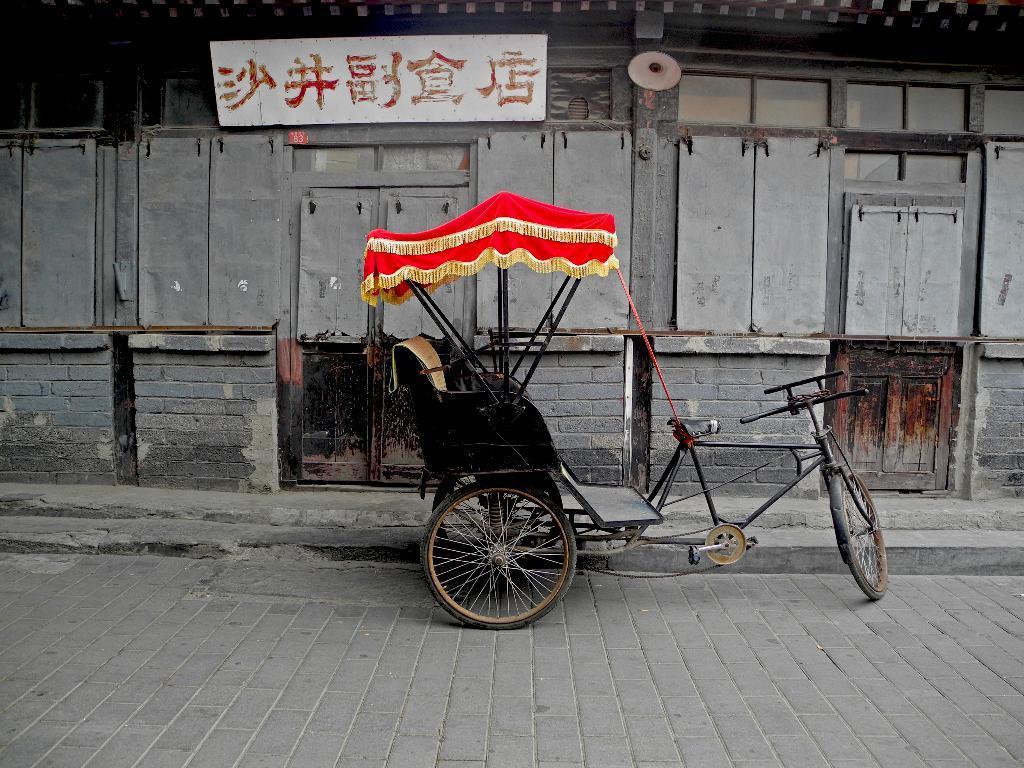Can you describe this image briefly? In the middle of this image, there is a rickshaw parked on a road. In the background, there is a hoarding attached to a wall of a building. 